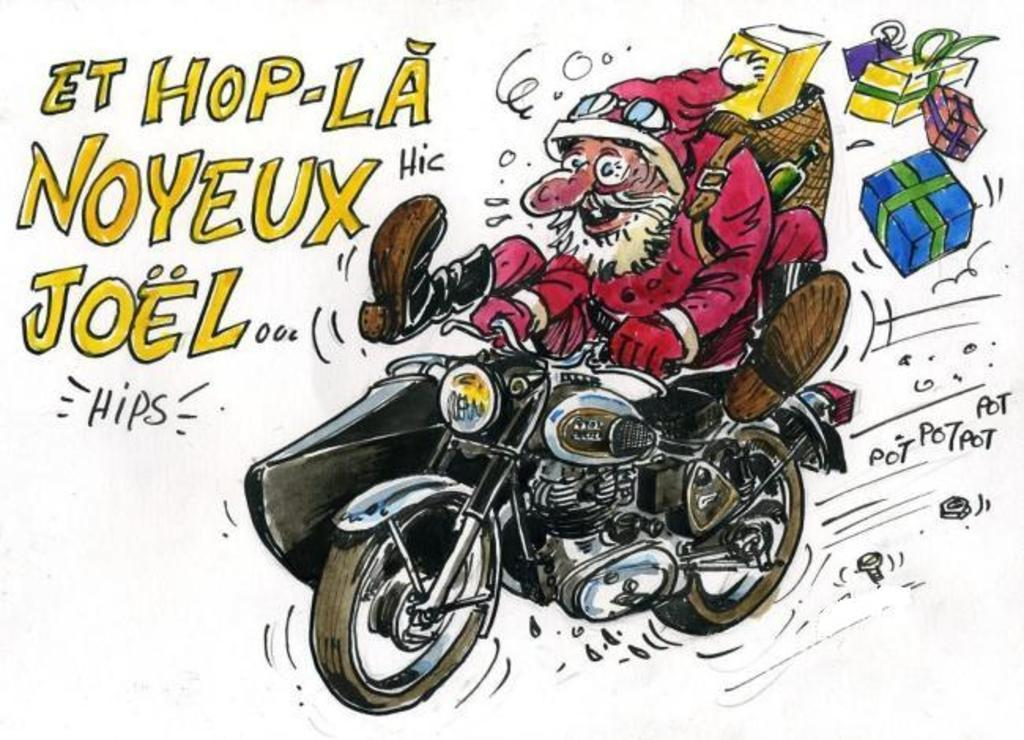What is depicted in the image? There is a sketch of a cartoon in the image. What is Santa doing in the cartoon? Santa is riding a bike in the cartoon. What is Santa holding in the cartoon? Santa is holding gifts in the cartoon. What else can be seen in the image besides the cartoon? There is text present in the image. How much money is Santa holding in the image? Santa is not holding money in the image; he is holding gifts. Is there a chair visible in the image? There is no chair present in the image. 